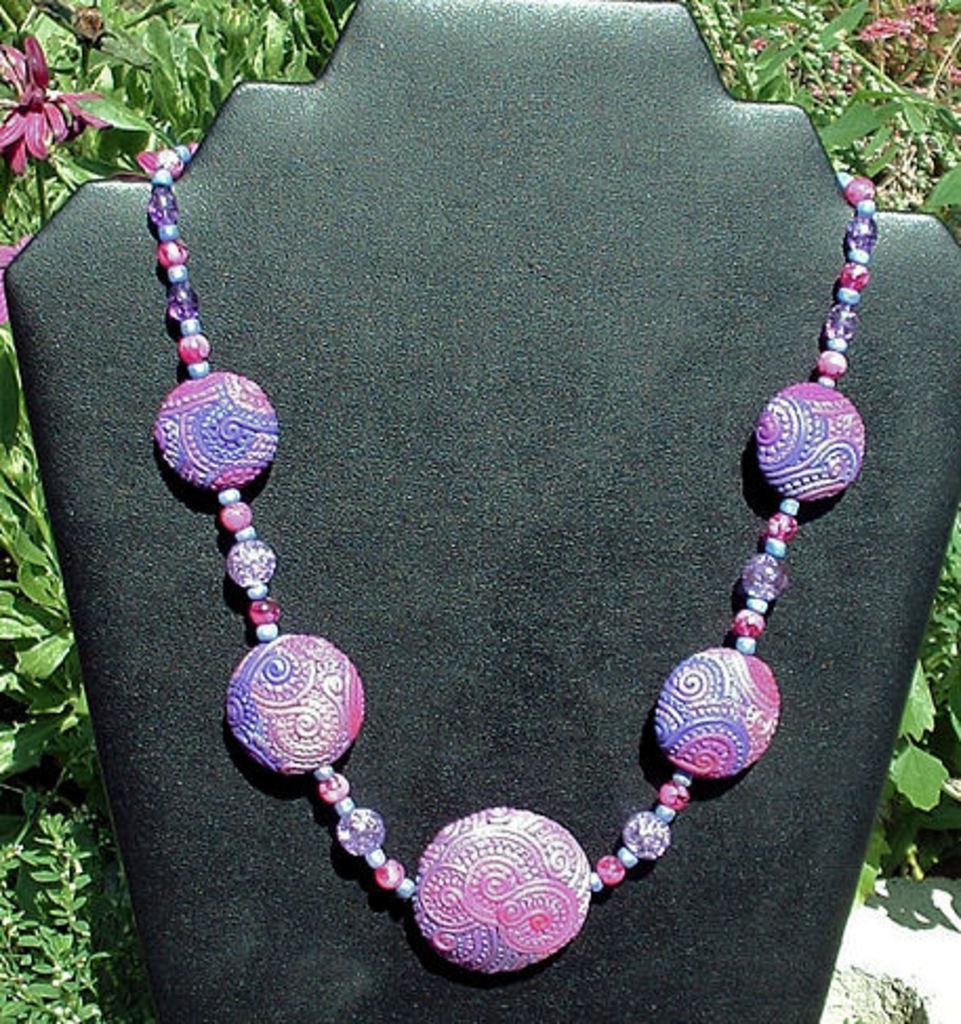In one or two sentences, can you explain what this image depicts? As we can see in image there is a black colour sheet on which there is a beads of necklace and in between beads there are five circles and they are very colourful and attractive. Behind the black sheep there are plants and on the plants there are flowers of pink colour. 